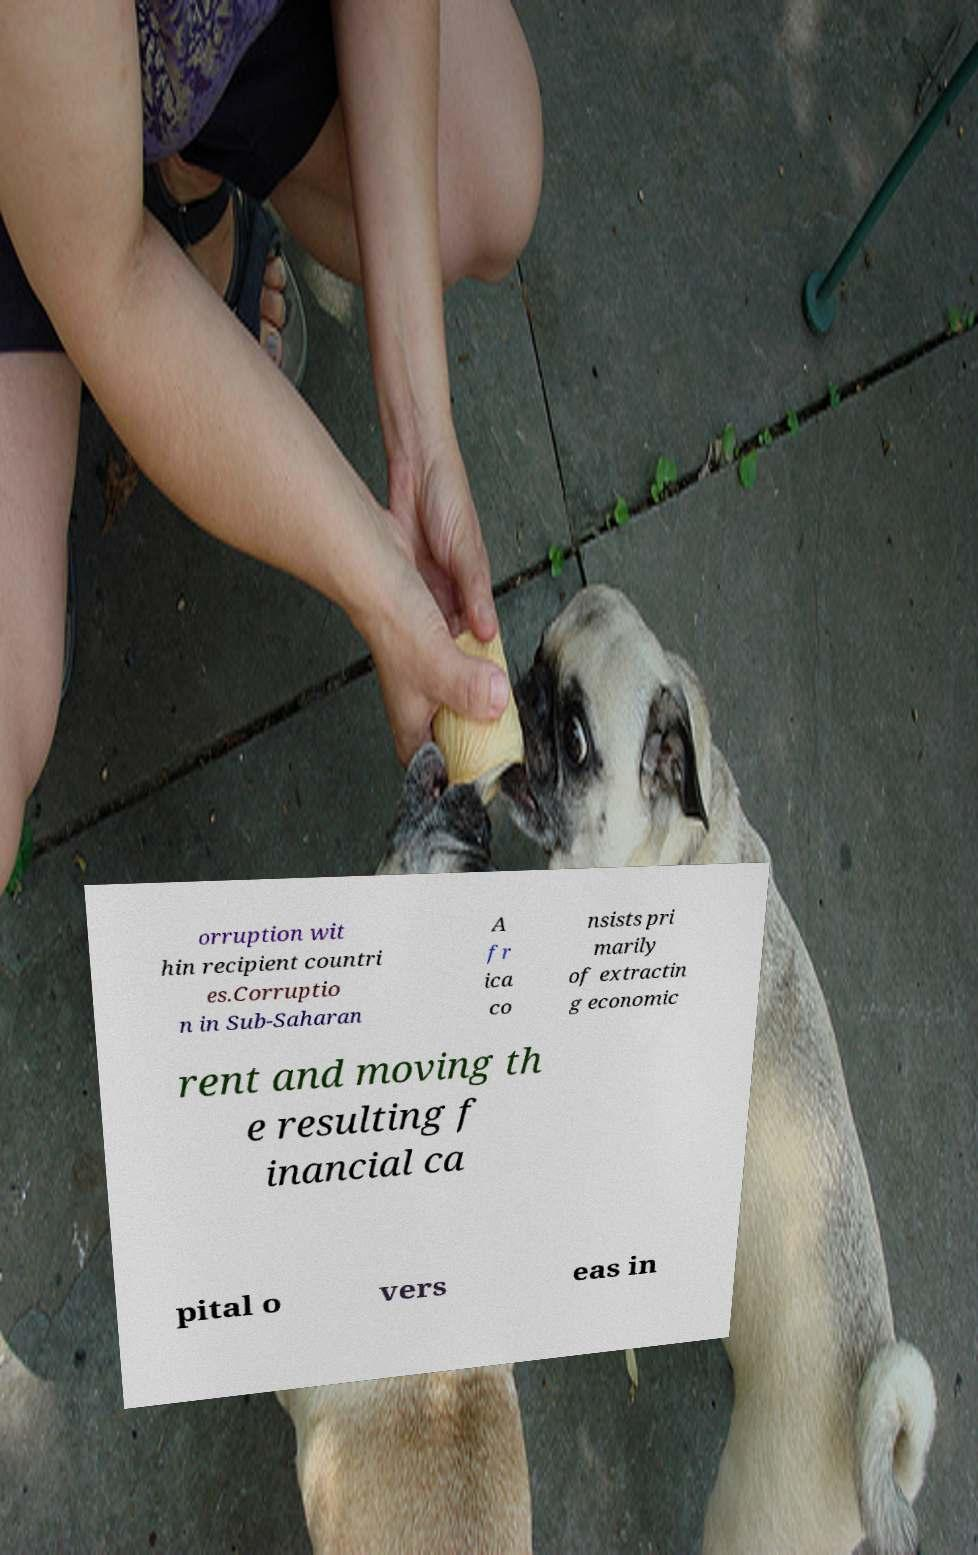Can you accurately transcribe the text from the provided image for me? orruption wit hin recipient countri es.Corruptio n in Sub-Saharan A fr ica co nsists pri marily of extractin g economic rent and moving th e resulting f inancial ca pital o vers eas in 